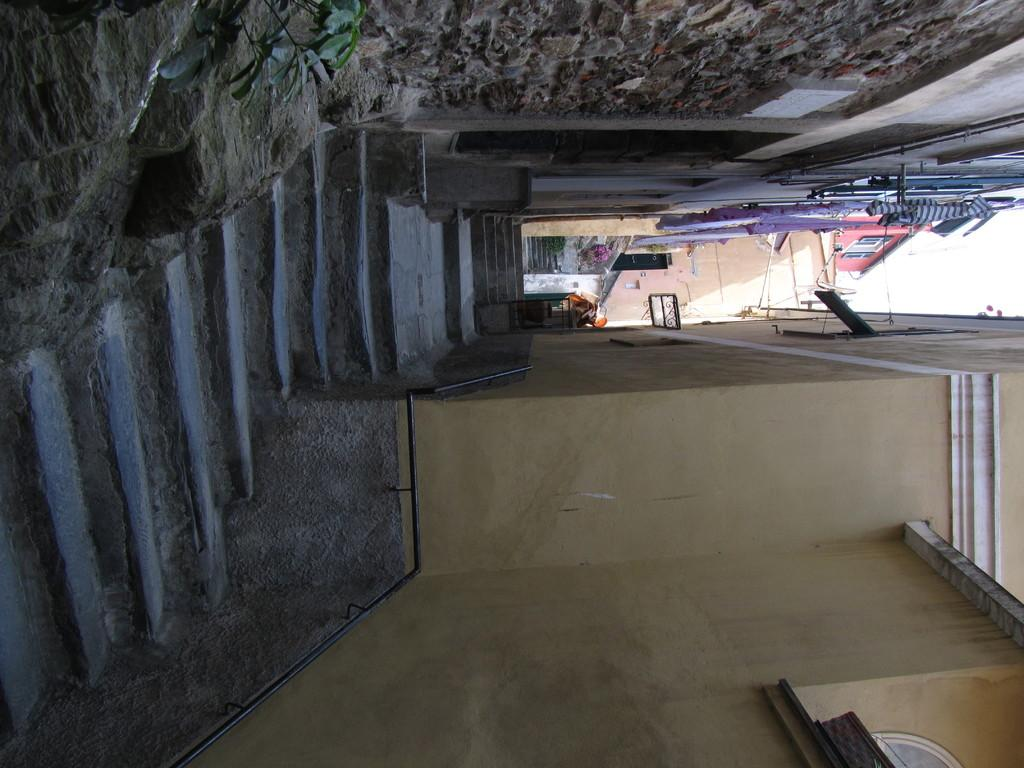What type of structures can be seen in the image? There are buildings in the image. Are there any architectural features visible in the image? Yes, there are stairs in the image. What can be seen on the ground in the image? The ground is visible in the image with some objects. What type of vegetation is present at the top of the image? There are plants at the top of the image. What is visible in the background of the image? The sky is visible in the image. Can you see any wood or roots in the image? There is no wood or roots present in the image. Is there a stream visible in the image? There is no stream present in the image. 